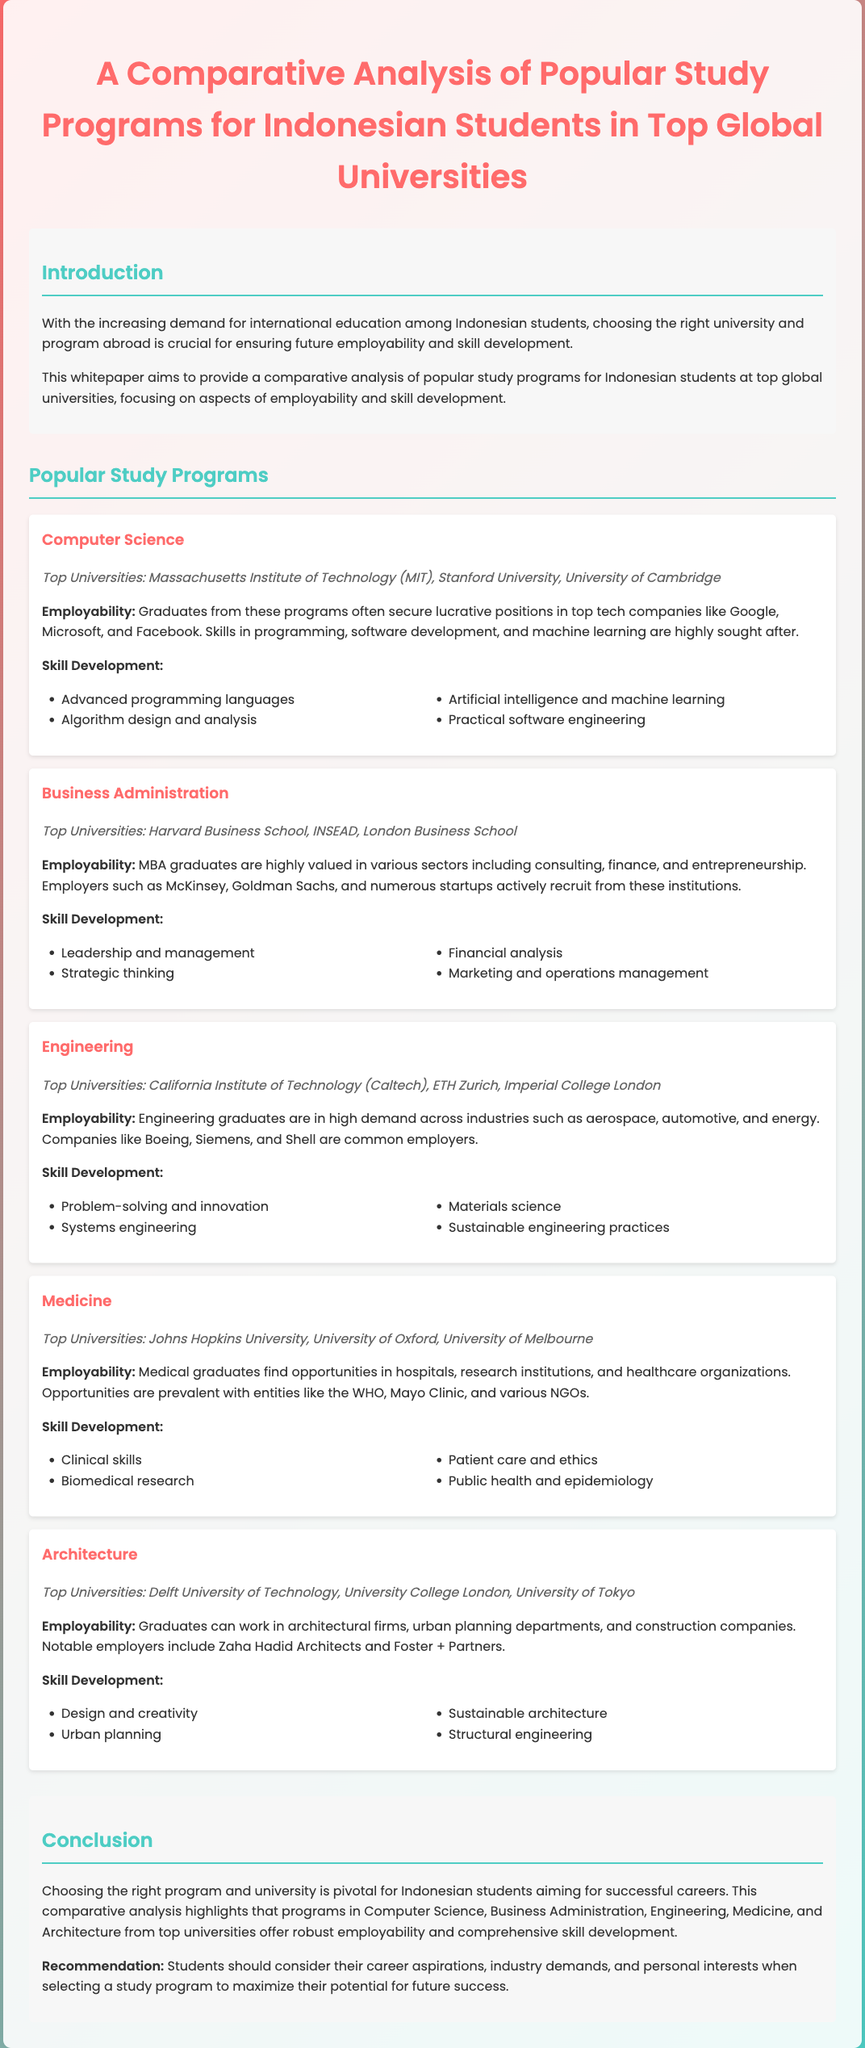what is the main focus of the whitepaper? The main focus of the whitepaper is to provide a comparative analysis of popular study programs for Indonesian students, particularly emphasizing employability and skill development.
Answer: employability and skill development which program is associated with the Massachusetts Institute of Technology? The program associated with the Massachusetts Institute of Technology is Computer Science.
Answer: Computer Science name a top university for Medicine mentioned in the document. The document mentions Johns Hopkins University as a top university for Medicine.
Answer: Johns Hopkins University what skills are highlighted in the skill development section for Engineering? The skills highlighted in the skill development section for Engineering include problem-solving and innovation, systems engineering, materials science, and sustainable engineering practices.
Answer: problem-solving and innovation, systems engineering, materials science, sustainable engineering practices which employers are noted for recruiting MBA graduates? The employers noted for recruiting MBA graduates include McKinsey, Goldman Sachs, and numerous startups.
Answer: McKinsey, Goldman Sachs, numerous startups what is a key recommendation given in the conclusion? A key recommendation given in the conclusion is that students should consider their career aspirations, industry demands, and personal interests when selecting a study program.
Answer: consider their career aspirations, industry demands, and personal interests how many popular study programs are analyzed in the document? The document analyzes five popular study programs for Indonesian students.
Answer: five which program offers skills in advanced programming languages? The program that offers skills in advanced programming languages is Computer Science.
Answer: Computer Science what type of document is this whitepaper classified as? This document is classified as a whitepaper focused on educational analysis.
Answer: whitepaper 